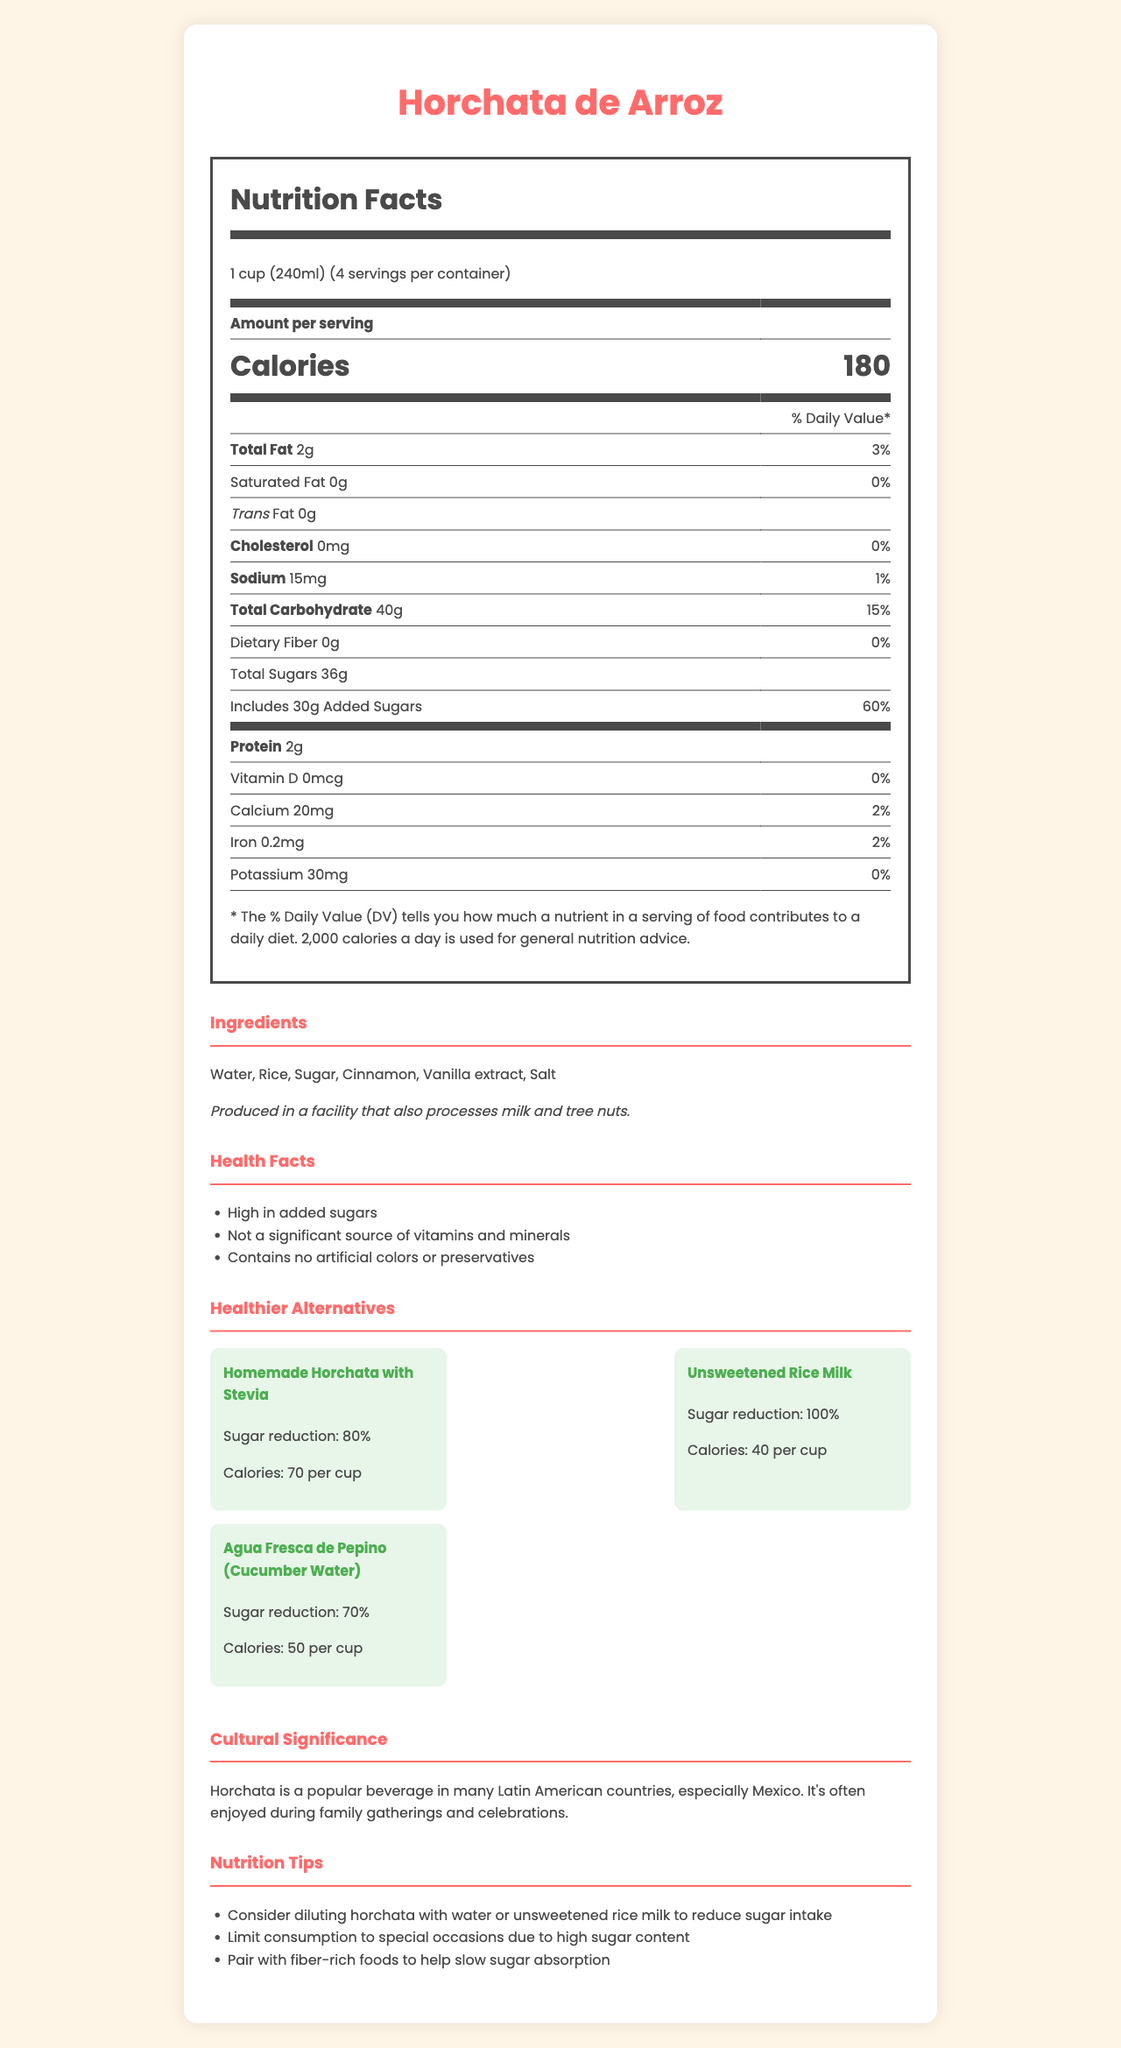what is the serving size of Horchata de Arroz? The serving size is listed as "1 cup (240ml)" under the product name and nutrition facts.
Answer: 1 cup (240ml) how many calories are in one serving of Horchata de Arroz? The number of calories per serving is specified as "180" in the nutrition facts section.
Answer: 180 what is the amount of added sugars in one serving? The added sugars are listed as "30g" in the total sugars section of the nutrition facts label.
Answer: 30g what are the main ingredients of Horchata de Arroz? The ingredients are listed under the ingredients section of the document.
Answer: Water, Rice, Sugar, Cinnamon, Vanilla extract, Salt what percentage of the daily value does the added sugars in one serving of Horchata de Arroz represent? The added sugars contribute to 60% of the daily value as shown in the nutrition facts section.
Answer: 60% which of these alternatives has the least amount of calories? A. Homemade Horchata with Stevia B. Unsweetened Rice Milk C. Agua Fresca de Pepino (Cucumber Water) Unsweetened Rice Milk has 40 calories per cup, which is the least compared to the other options.
Answer: B what is the total carbohydrate content in one serving of Horchata de Arroz? The total carbohydrates are listed as "40g" in the nutrition facts section.
Answer: 40g which of these health facts does not apply to Horchata de Arroz? A. High in calcium B. High in added sugars C. Contains no artificial colors or preservatives The document states that it is "High in added sugars" and "Contains no artificial colors or preservatives," but it mentions that it is "Not a significant source of vitamins and minerals" which includes calcium.
Answer: A does Horchata de Arroz contain any dietary fiber? The dietary fiber content listed in the nutrition facts section is "0g".
Answer: No summarize the main idea of the document. The summary encompasses the nutrition information, ingredients, health facts, cultural significance, and suggested alternatives provided in the document.
Answer: The document provides nutrition facts, ingredients, health facts, and healthier alternatives for Horchata de Arroz, a popular Hispanic beverage. It highlights the high sugar content and suggests limiting consumption or choosing alternatives to reduce sugar intake. what is the cultural significance of Horchata de Arroz? The cultural significance is explicitly described in the cultural significance section of the document.
Answer: Horchata is a popular beverage in many Latin American countries, especially Mexico. It's often enjoyed during family gatherings and celebrations. how much sodium is in one serving of Horchata de Arroz? The sodium content is listed as "15mg" under the nutrition facts section.
Answer: 15mg what facilities produce Horchata de Arroz? The allergen information section states that it is produced in a facility that processes milk and tree nuts.
Answer: Produced in a facility that also processes milk and tree nuts. can the calorie content of Horchata de Arroz be determined without knowing the serving size? Without the serving size, it's difficult to accurately determine the calorie content per serving.
Answer: Not enough information how much protein is in one serving of Horchata de Arroz? The protein content is listed as "2g" in the nutrition facts section.
Answer: 2g what are two healthier alternatives to Horchata de Arroz? The alternatives section lists "Homemade Horchata with Stevia" and "Unsweetened Rice Milk" as healthier options.
Answer: Homemade Horchata with Stevia and Unsweetened Rice Milk 